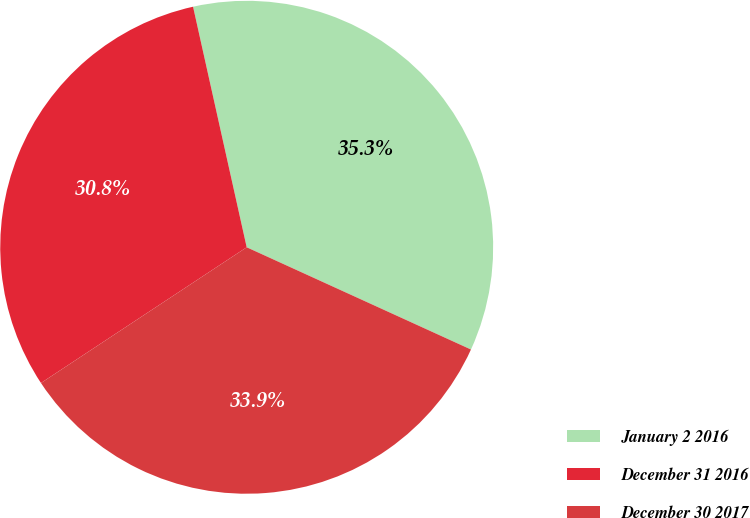Convert chart. <chart><loc_0><loc_0><loc_500><loc_500><pie_chart><fcel>January 2 2016<fcel>December 31 2016<fcel>December 30 2017<nl><fcel>35.3%<fcel>30.79%<fcel>33.91%<nl></chart> 